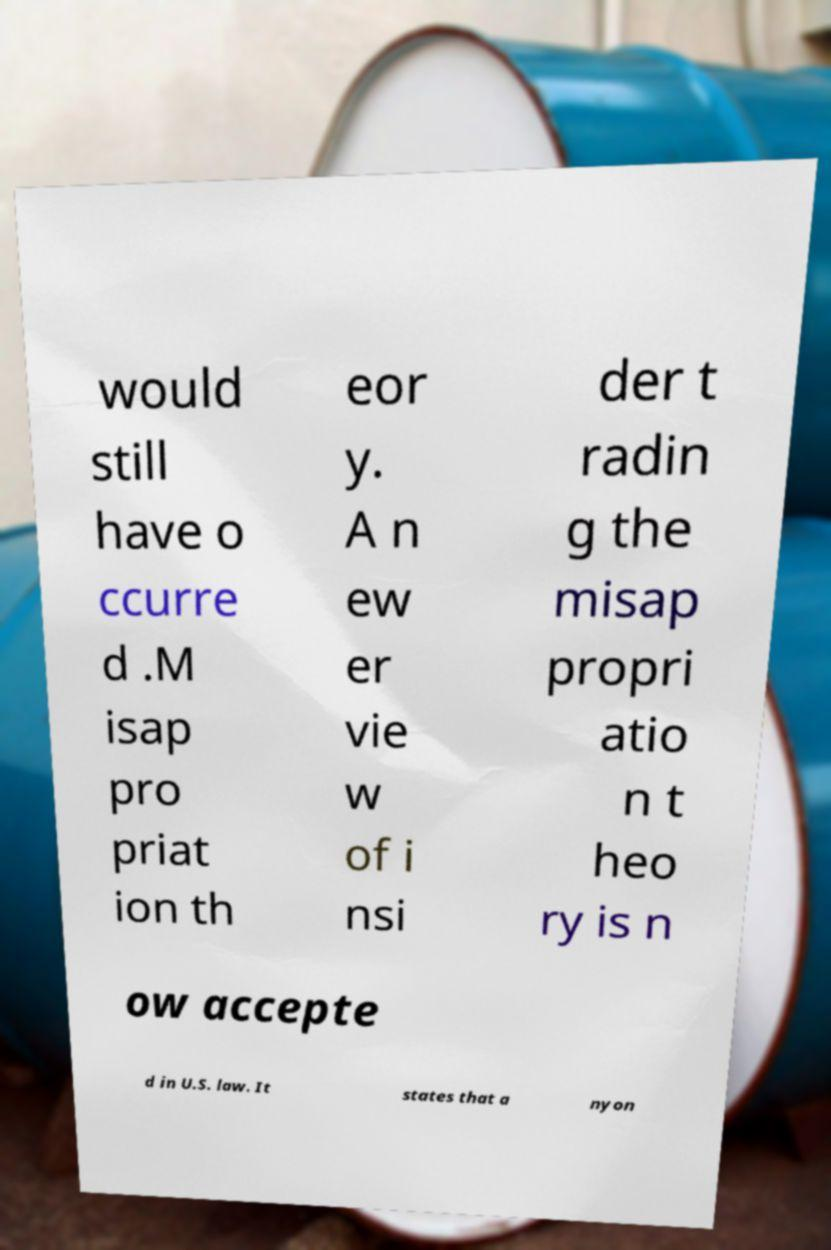Could you extract and type out the text from this image? would still have o ccurre d .M isap pro priat ion th eor y. A n ew er vie w of i nsi der t radin g the misap propri atio n t heo ry is n ow accepte d in U.S. law. It states that a nyon 